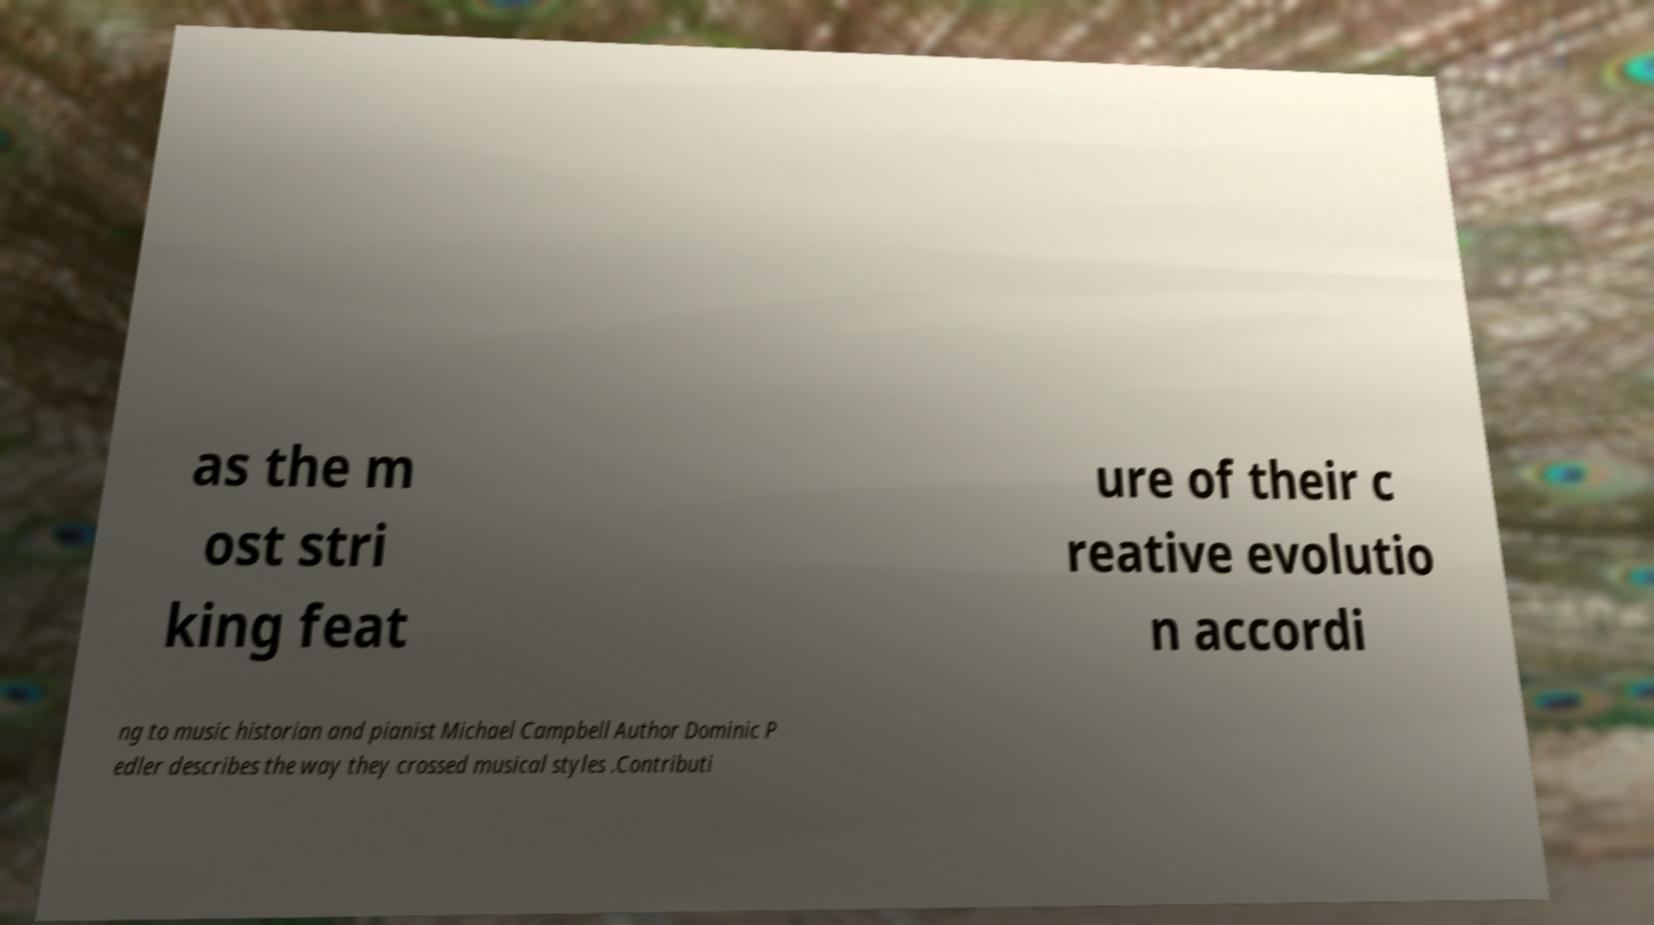There's text embedded in this image that I need extracted. Can you transcribe it verbatim? as the m ost stri king feat ure of their c reative evolutio n accordi ng to music historian and pianist Michael Campbell Author Dominic P edler describes the way they crossed musical styles .Contributi 